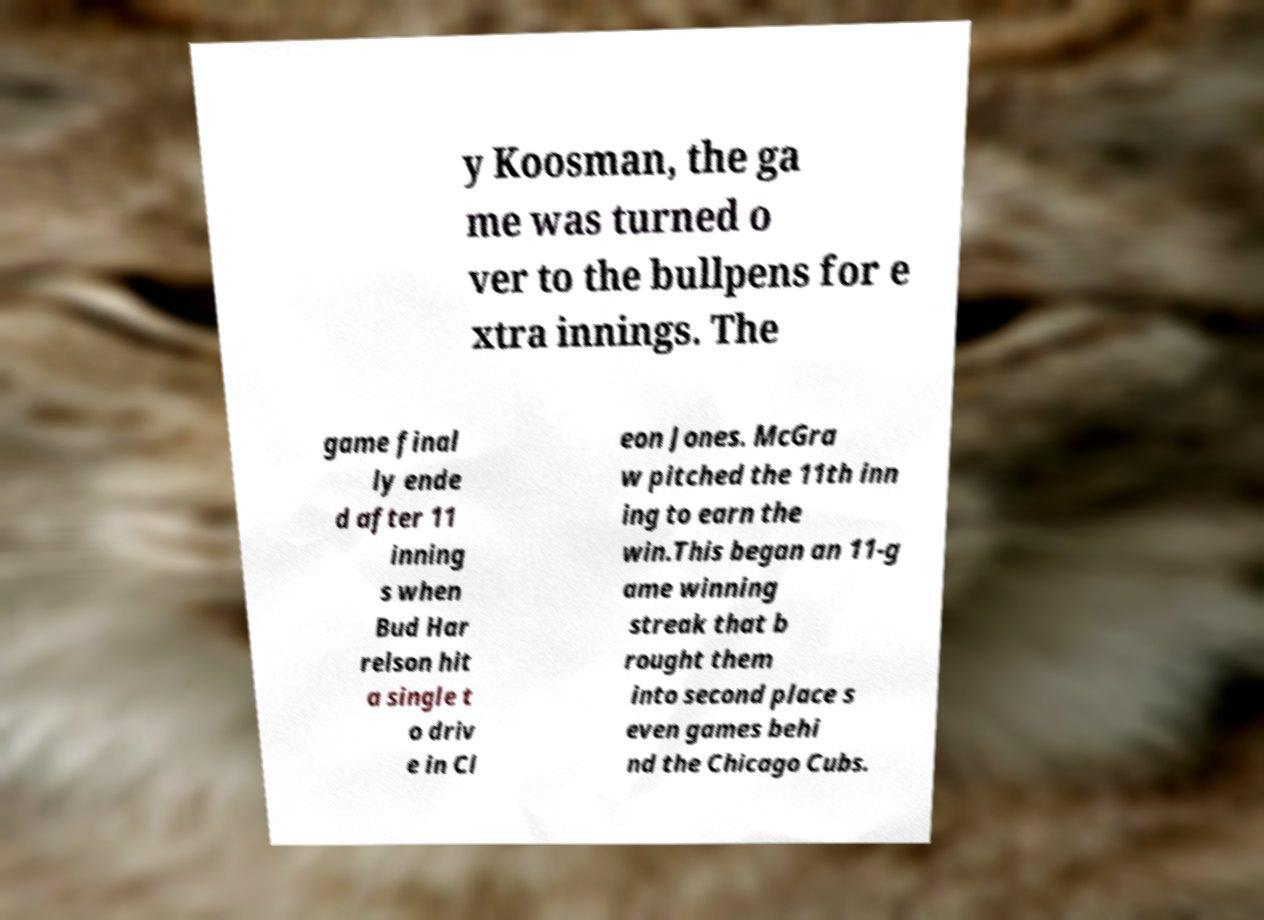For documentation purposes, I need the text within this image transcribed. Could you provide that? y Koosman, the ga me was turned o ver to the bullpens for e xtra innings. The game final ly ende d after 11 inning s when Bud Har relson hit a single t o driv e in Cl eon Jones. McGra w pitched the 11th inn ing to earn the win.This began an 11-g ame winning streak that b rought them into second place s even games behi nd the Chicago Cubs. 